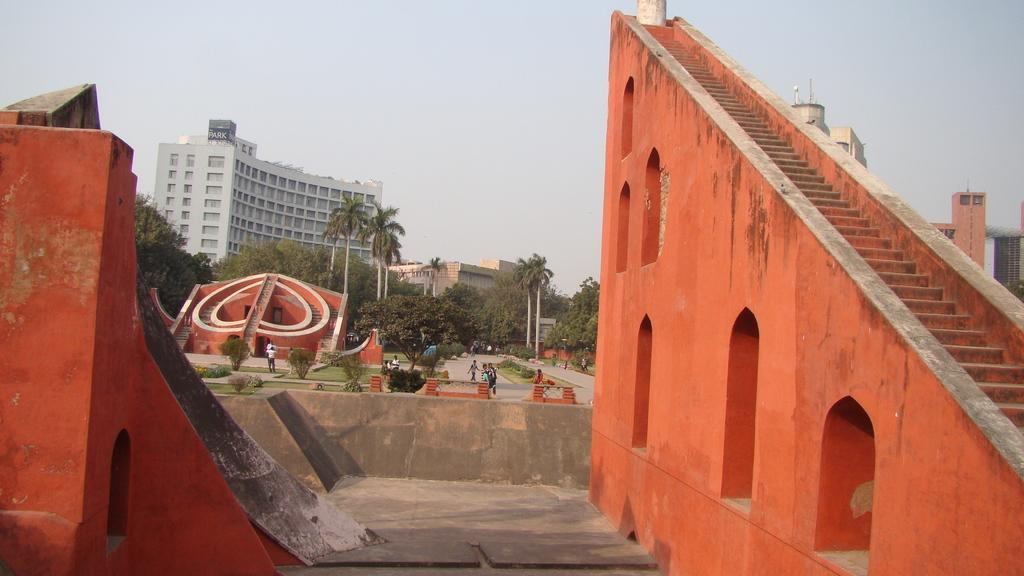What type of architectural feature is present in the image? There are steps in the image. What is the color of the walls in the image? The walls in the image are orange in color. What type of natural elements can be seen in the image? There are trees in the image. What type of man-made structures are visible in the image? There are buildings in the image. Are there any living beings present in the image? Yes, there are people in the image. What is visible in the background of the image? The sky is visible in the background of the image. Can you see a ghost interacting with the people in the image? There is no ghost present in the image. What type of exchange is taking place between the people in the image? The image does not provide enough information to determine the nature of any exchange between the people. 